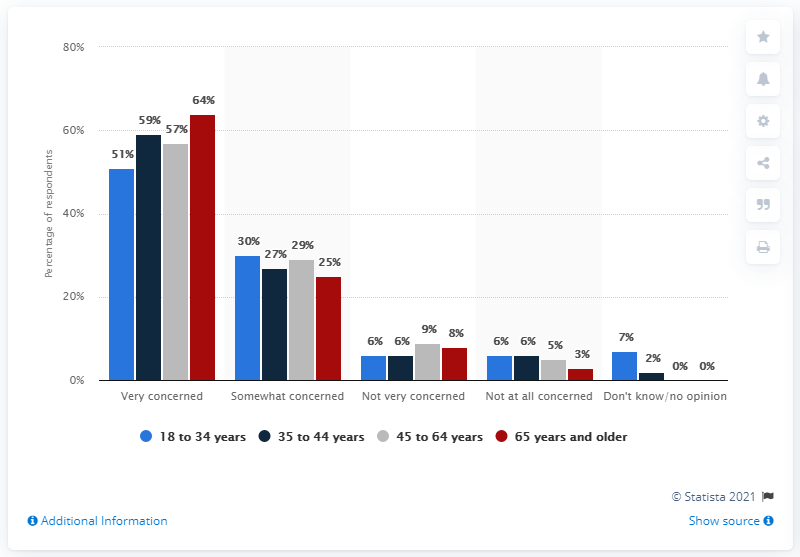Identify some key points in this picture. In October 2020, a survey found that 6% of adults in the United States were very concerned about the new coronavirus outbreak, while 18-34 year olds who were not very concerned about the outbreak made up 6% of that group. In October 2020, the proportion of adults in the United States who were concerned about the new coronavirus outbreak was 29%, among all groups that were not very concerned about the outbreak. 